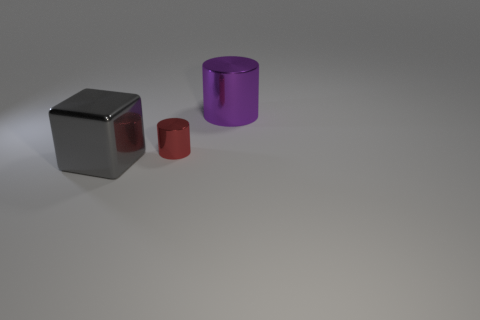Add 3 small red metallic things. How many objects exist? 6 Subtract all cylinders. How many objects are left? 1 Add 3 tiny red shiny things. How many tiny red shiny things exist? 4 Subtract 1 purple cylinders. How many objects are left? 2 Subtract all big gray cubes. Subtract all large things. How many objects are left? 0 Add 1 large gray cubes. How many large gray cubes are left? 2 